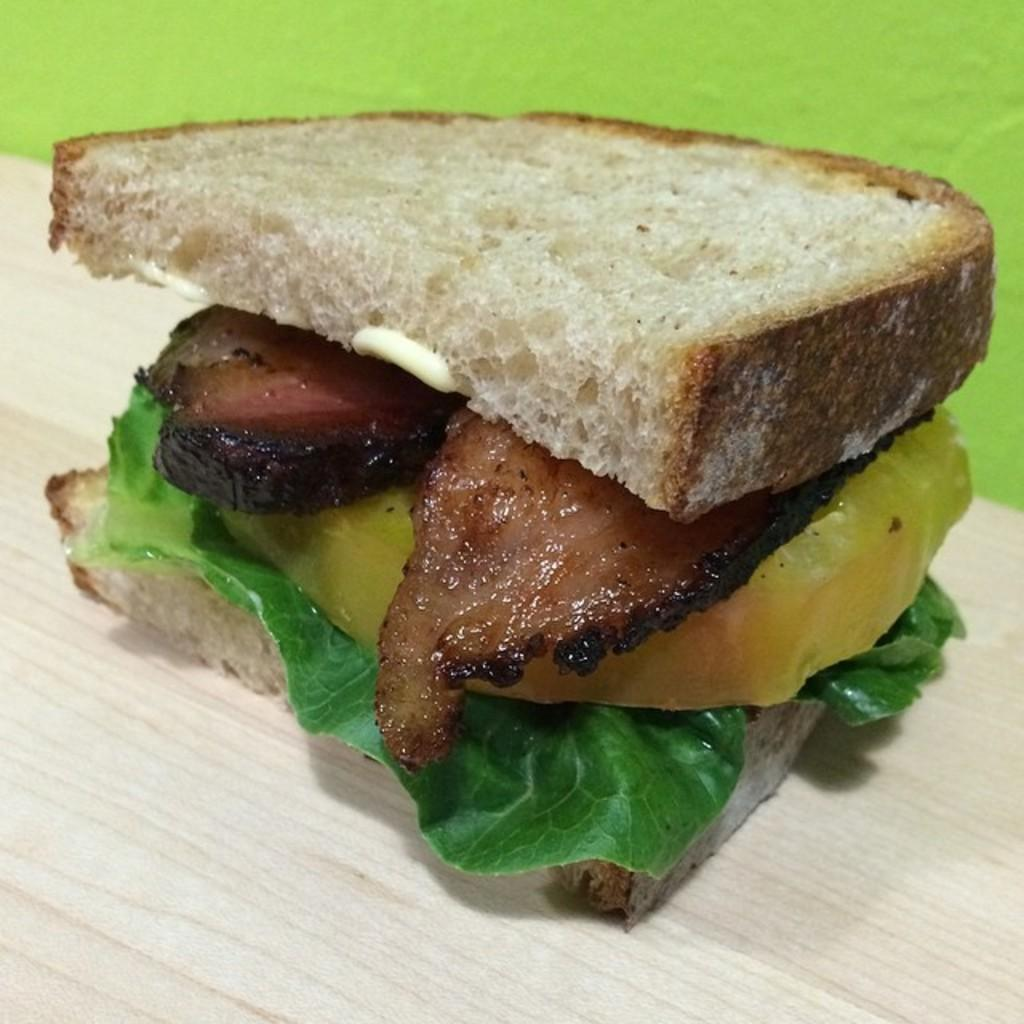What is the main subject of the image? There is a food item in the image. Can you describe the surface on which the food item is placed? The food item is on a wooden surface. Is the food item in the image being used as a quiver for arrows? No, the food item in the image is not being used as a quiver for arrows. What type of learning can be observed in the image? There is no learning activity depicted in the image; it only shows a food item on a wooden surface. 